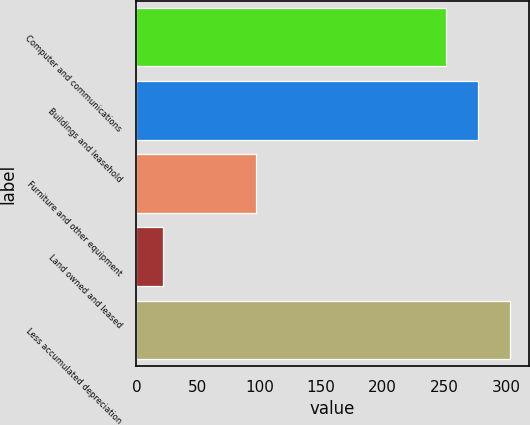Convert chart to OTSL. <chart><loc_0><loc_0><loc_500><loc_500><bar_chart><fcel>Computer and communications<fcel>Buildings and leasehold<fcel>Furniture and other equipment<fcel>Land owned and leased<fcel>Less accumulated depreciation<nl><fcel>251.5<fcel>277.52<fcel>97<fcel>21.5<fcel>303.54<nl></chart> 